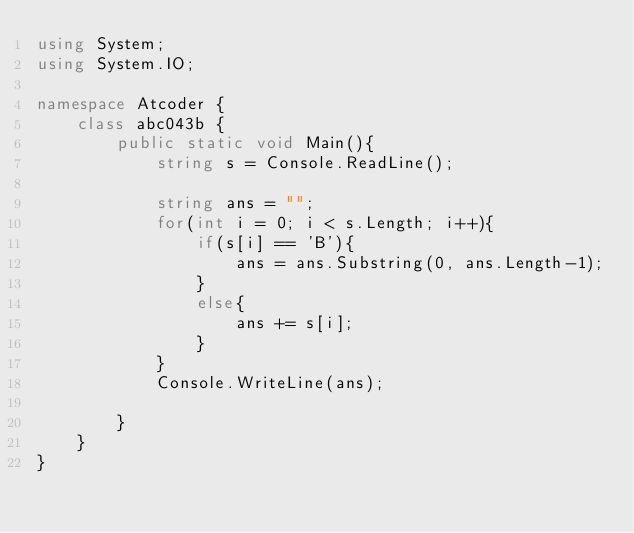Convert code to text. <code><loc_0><loc_0><loc_500><loc_500><_C#_>using System;
using System.IO;

namespace Atcoder {
    class abc043b {
        public static void Main(){
            string s = Console.ReadLine();

            string ans = "";
            for(int i = 0; i < s.Length; i++){
                if(s[i] == 'B'){
                    ans = ans.Substring(0, ans.Length-1);
                }
                else{
                    ans += s[i];
                }
            }
            Console.WriteLine(ans);

        }
    }
}
</code> 